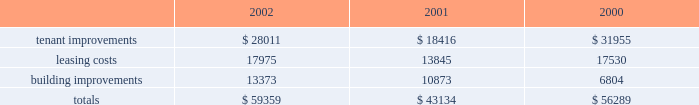D u k e r e a l t y c o r p o r a t i o n 1 6 2 0 0 2 a n n u a l r e p o r t management 2019s discussion and analysis of financial conditionand results of operations the indenture governing the company 2019s unsecured notes also requires the company to comply with financial ratios and other covenants regarding the operations of the company .
The company is currently in compliance with all such covenants and expects to remain in compliance in the foreseeable future .
In january 2003 , the company completed an issuance of unsecured debt totaling $ 175 million bearing interest at 5.25% ( 5.25 % ) , due 2010 .
Sale of real estate assets the company utilizes sales of real estate assets as an additional source of liquidity .
During 2000 and 2001 , the company engaged in a capital-recycling program that resulted in sales of over $ 1 billion of real estate assets during these two years .
In 2002 , this program was substantially reduced as capital needs were met through other sources and the slower business climate provided few opportunities to profitably reinvest sales proceeds .
The company continues to pursue opportunities to sell real estate assets when beneficial to the long-term strategy of the company .
Uses of liquidity the company 2019s principal uses of liquidity include the following : 2022 property investments and recurring leasing/capital costs ; 2022 dividends and distributions to shareholders and unitholders ; 2022 long-term debt maturities ; and 2022 the company 2019s common stock repurchase program .
Property investments and other capital expenditures one of the company 2019s principal uses of its liquidity is for the development , acquisition and recurring leasing/capital expendi- tures of its real estate investments .
A summary of the company 2019s recurring capital expenditures is as follows ( in thousands ) : dividends and distributions in order to qualify as a reit for federal income tax purposes , the company must currently distribute at least 90% ( 90 % ) of its taxable income to its shareholders and duke realty limited partnership ( 201cdrlp 201d ) unitholders .
The company paid dividends of $ 1.81 , $ 1.76 and $ 1.64 for the years ended december 31 , 2002 , 2001 and 2000 , respectively .
The company expects to continue to distribute taxable earnings to meet the requirements to maintain its reit status .
However , distributions are declared at the discretion of the company 2019s board of directors and are subject to actual cash available for distribution , the company 2019s financial condition , capital requirements and such other factors as the company 2019s board of directors deems relevant .
Debt maturities debt outstanding at december 31 , 2002 , totaled $ 2.1 billion with a weighted average interest rate of 6.25% ( 6.25 % ) maturing at various dates through 2028 .
The company had $ 1.8 billion of unsecured debt and $ 299.1 million of secured debt outstanding at december 31 , 2002 .
Scheduled principal amortization of such debt totaled $ 10.9 million for the year ended december 31 , 2002 .
Following is a summary of the scheduled future amortization and maturities of the company 2019s indebtedness at december 31 , 2002 ( in thousands ) : .

At december 31 , 2002 what was the ratio of the company unsecured debt to the secured debt outstanding? 
Computations: (1.8 / 299.1)
Answer: 0.00602. 